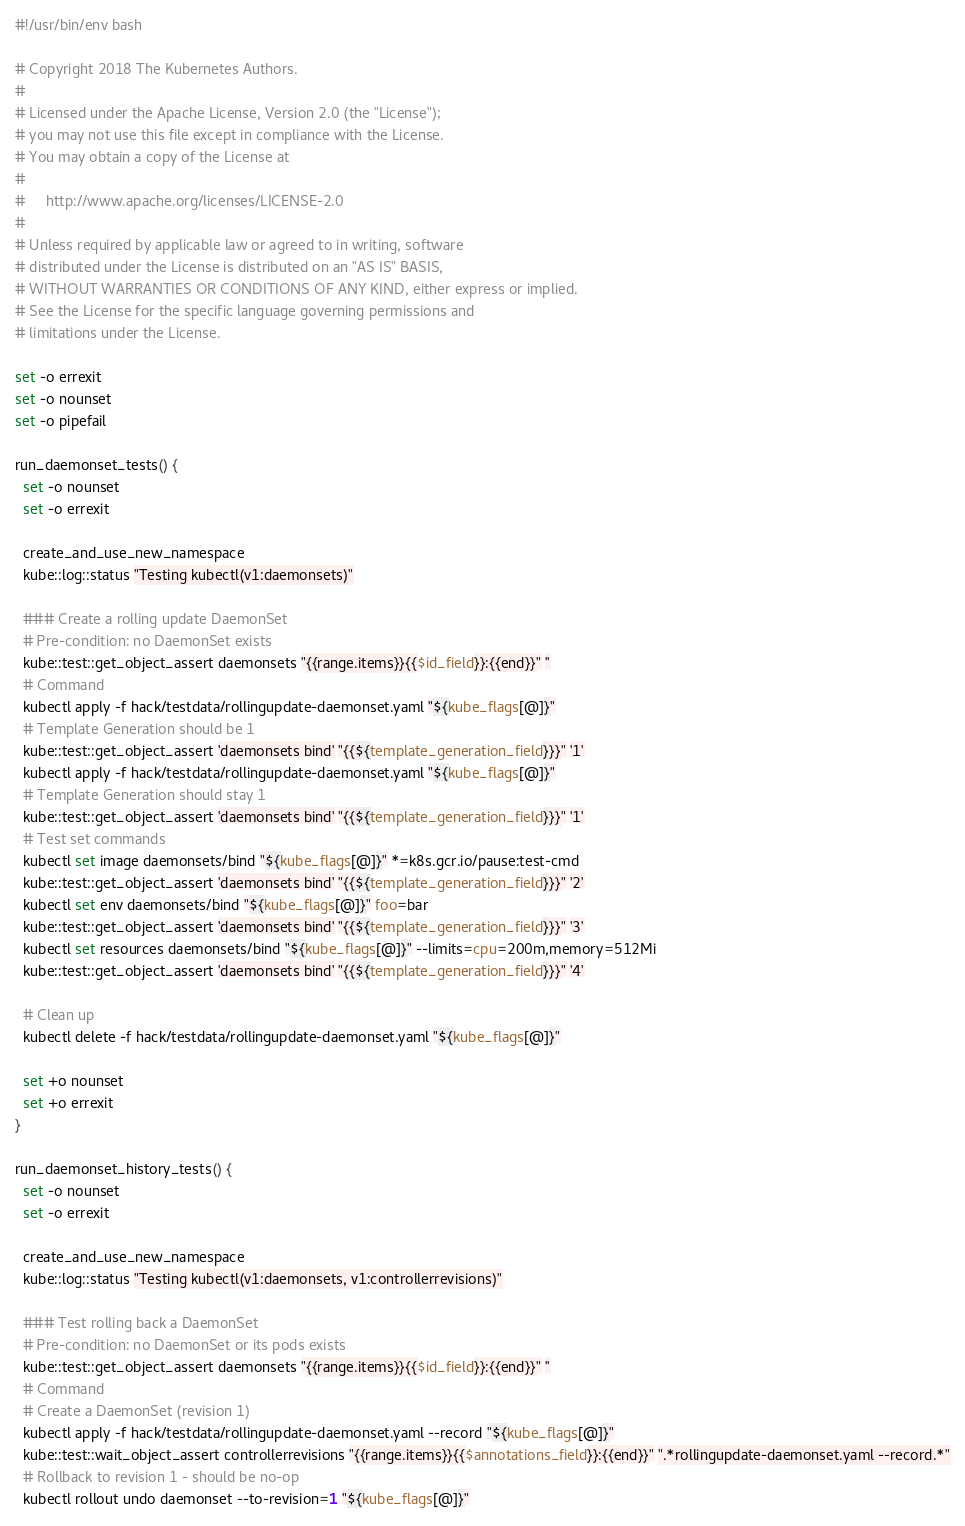Convert code to text. <code><loc_0><loc_0><loc_500><loc_500><_Bash_>#!/usr/bin/env bash

# Copyright 2018 The Kubernetes Authors.
#
# Licensed under the Apache License, Version 2.0 (the "License");
# you may not use this file except in compliance with the License.
# You may obtain a copy of the License at
#
#     http://www.apache.org/licenses/LICENSE-2.0
#
# Unless required by applicable law or agreed to in writing, software
# distributed under the License is distributed on an "AS IS" BASIS,
# WITHOUT WARRANTIES OR CONDITIONS OF ANY KIND, either express or implied.
# See the License for the specific language governing permissions and
# limitations under the License.

set -o errexit
set -o nounset
set -o pipefail

run_daemonset_tests() {
  set -o nounset
  set -o errexit

  create_and_use_new_namespace
  kube::log::status "Testing kubectl(v1:daemonsets)"

  ### Create a rolling update DaemonSet
  # Pre-condition: no DaemonSet exists
  kube::test::get_object_assert daemonsets "{{range.items}}{{$id_field}}:{{end}}" ''
  # Command
  kubectl apply -f hack/testdata/rollingupdate-daemonset.yaml "${kube_flags[@]}"
  # Template Generation should be 1
  kube::test::get_object_assert 'daemonsets bind' "{{${template_generation_field}}}" '1'
  kubectl apply -f hack/testdata/rollingupdate-daemonset.yaml "${kube_flags[@]}"
  # Template Generation should stay 1
  kube::test::get_object_assert 'daemonsets bind' "{{${template_generation_field}}}" '1'
  # Test set commands
  kubectl set image daemonsets/bind "${kube_flags[@]}" *=k8s.gcr.io/pause:test-cmd
  kube::test::get_object_assert 'daemonsets bind' "{{${template_generation_field}}}" '2'
  kubectl set env daemonsets/bind "${kube_flags[@]}" foo=bar
  kube::test::get_object_assert 'daemonsets bind' "{{${template_generation_field}}}" '3'
  kubectl set resources daemonsets/bind "${kube_flags[@]}" --limits=cpu=200m,memory=512Mi
  kube::test::get_object_assert 'daemonsets bind' "{{${template_generation_field}}}" '4'

  # Clean up
  kubectl delete -f hack/testdata/rollingupdate-daemonset.yaml "${kube_flags[@]}"

  set +o nounset
  set +o errexit
}

run_daemonset_history_tests() {
  set -o nounset
  set -o errexit

  create_and_use_new_namespace
  kube::log::status "Testing kubectl(v1:daemonsets, v1:controllerrevisions)"

  ### Test rolling back a DaemonSet
  # Pre-condition: no DaemonSet or its pods exists
  kube::test::get_object_assert daemonsets "{{range.items}}{{$id_field}}:{{end}}" ''
  # Command
  # Create a DaemonSet (revision 1)
  kubectl apply -f hack/testdata/rollingupdate-daemonset.yaml --record "${kube_flags[@]}"
  kube::test::wait_object_assert controllerrevisions "{{range.items}}{{$annotations_field}}:{{end}}" ".*rollingupdate-daemonset.yaml --record.*"
  # Rollback to revision 1 - should be no-op
  kubectl rollout undo daemonset --to-revision=1 "${kube_flags[@]}"</code> 